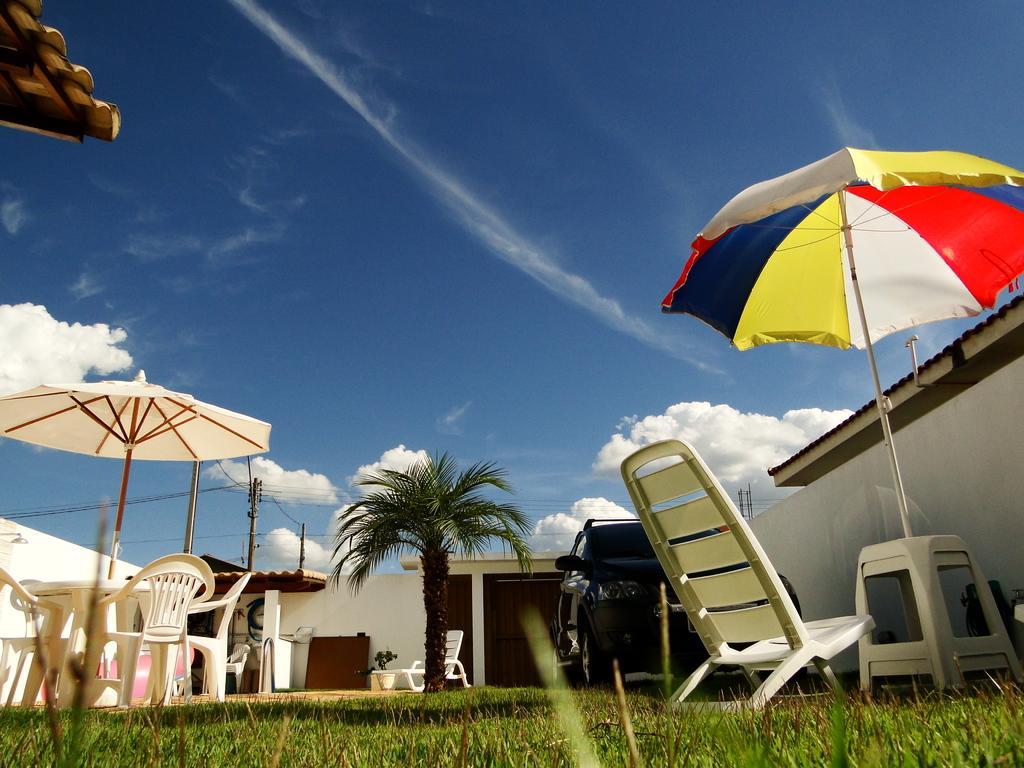Can you describe this image briefly? In this image we can see the umbrellas, chairs, table, stools, wall and also the roofs for shelter. We can also see the electrical poles with wires. There is also a car, flower pot and also the grass at the bottom. In the background we can see the sky with some clouds. 